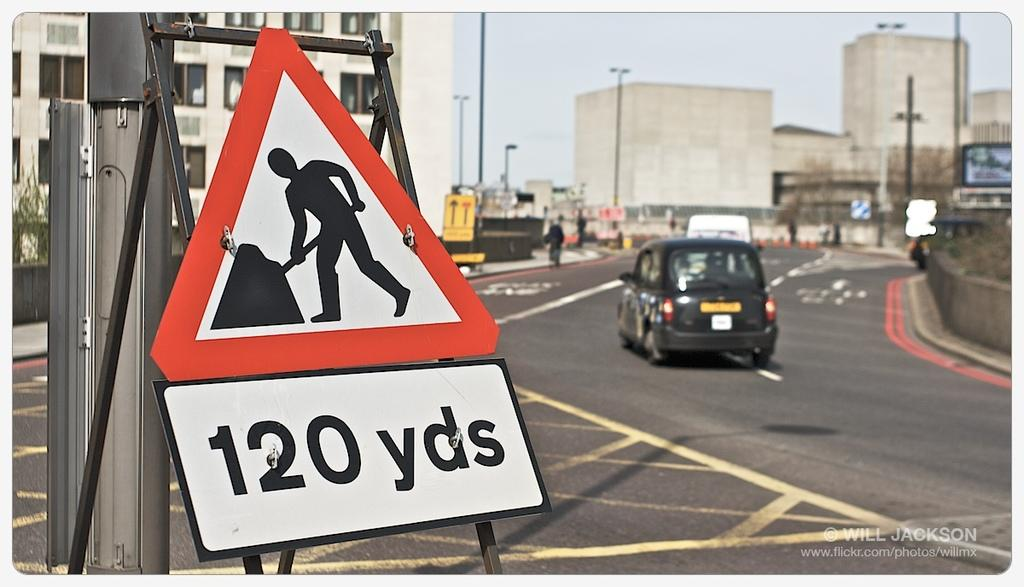<image>
Summarize the visual content of the image. A warning workers road sign at 120 yards ahead on street. 